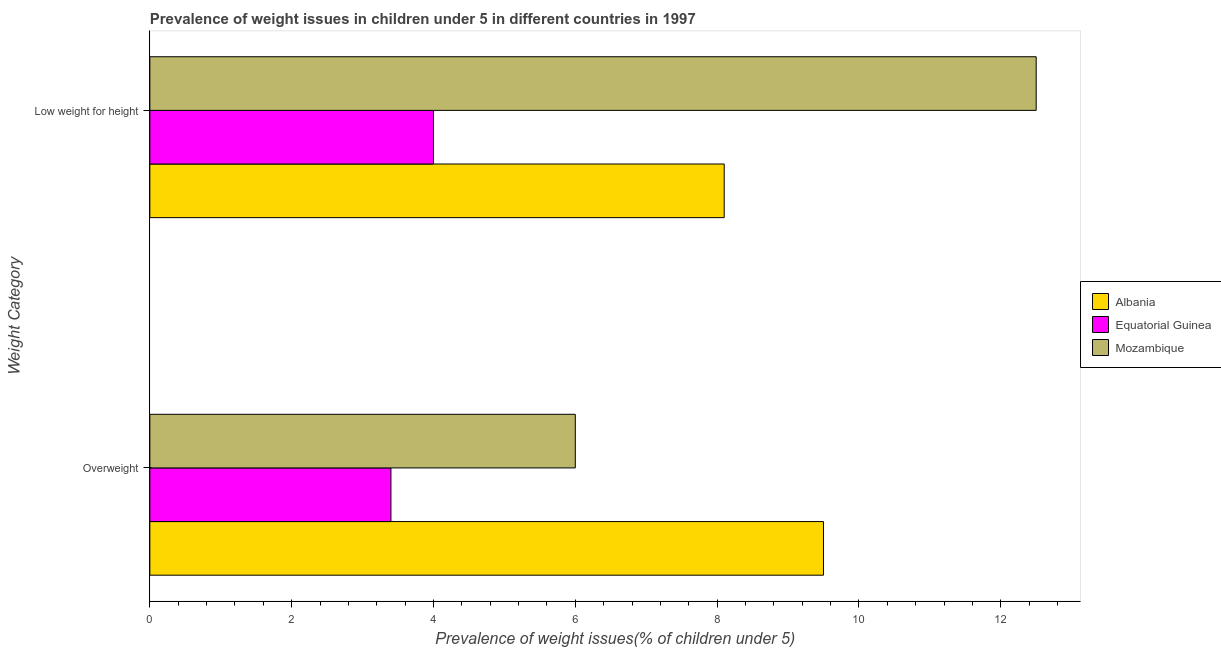How many different coloured bars are there?
Provide a short and direct response. 3. How many groups of bars are there?
Your answer should be very brief. 2. Are the number of bars on each tick of the Y-axis equal?
Keep it short and to the point. Yes. How many bars are there on the 2nd tick from the top?
Your answer should be compact. 3. What is the label of the 1st group of bars from the top?
Ensure brevity in your answer.  Low weight for height. Across all countries, what is the maximum percentage of overweight children?
Ensure brevity in your answer.  9.5. In which country was the percentage of overweight children maximum?
Keep it short and to the point. Albania. In which country was the percentage of underweight children minimum?
Provide a short and direct response. Equatorial Guinea. What is the total percentage of overweight children in the graph?
Give a very brief answer. 18.9. What is the difference between the percentage of overweight children in Albania and that in Equatorial Guinea?
Ensure brevity in your answer.  6.1. What is the difference between the percentage of underweight children in Albania and the percentage of overweight children in Mozambique?
Give a very brief answer. 2.1. What is the average percentage of underweight children per country?
Your answer should be very brief. 8.2. What is the difference between the percentage of underweight children and percentage of overweight children in Mozambique?
Provide a succinct answer. 6.5. In how many countries, is the percentage of overweight children greater than 8.4 %?
Offer a terse response. 1. What is the ratio of the percentage of overweight children in Albania to that in Equatorial Guinea?
Offer a terse response. 2.79. Is the percentage of overweight children in Equatorial Guinea less than that in Albania?
Keep it short and to the point. Yes. What does the 2nd bar from the top in Overweight represents?
Provide a short and direct response. Equatorial Guinea. What does the 1st bar from the bottom in Overweight represents?
Provide a short and direct response. Albania. Are all the bars in the graph horizontal?
Provide a short and direct response. Yes. How many countries are there in the graph?
Offer a very short reply. 3. Where does the legend appear in the graph?
Provide a succinct answer. Center right. What is the title of the graph?
Ensure brevity in your answer.  Prevalence of weight issues in children under 5 in different countries in 1997. What is the label or title of the X-axis?
Your answer should be compact. Prevalence of weight issues(% of children under 5). What is the label or title of the Y-axis?
Offer a very short reply. Weight Category. What is the Prevalence of weight issues(% of children under 5) in Equatorial Guinea in Overweight?
Keep it short and to the point. 3.4. What is the Prevalence of weight issues(% of children under 5) in Mozambique in Overweight?
Provide a succinct answer. 6. What is the Prevalence of weight issues(% of children under 5) of Albania in Low weight for height?
Your response must be concise. 8.1. What is the Prevalence of weight issues(% of children under 5) of Equatorial Guinea in Low weight for height?
Offer a terse response. 4. Across all Weight Category, what is the maximum Prevalence of weight issues(% of children under 5) of Albania?
Ensure brevity in your answer.  9.5. Across all Weight Category, what is the maximum Prevalence of weight issues(% of children under 5) of Equatorial Guinea?
Provide a short and direct response. 4. Across all Weight Category, what is the maximum Prevalence of weight issues(% of children under 5) of Mozambique?
Your answer should be very brief. 12.5. Across all Weight Category, what is the minimum Prevalence of weight issues(% of children under 5) of Albania?
Provide a succinct answer. 8.1. Across all Weight Category, what is the minimum Prevalence of weight issues(% of children under 5) in Equatorial Guinea?
Give a very brief answer. 3.4. Across all Weight Category, what is the minimum Prevalence of weight issues(% of children under 5) in Mozambique?
Offer a very short reply. 6. What is the total Prevalence of weight issues(% of children under 5) in Equatorial Guinea in the graph?
Your answer should be compact. 7.4. What is the total Prevalence of weight issues(% of children under 5) in Mozambique in the graph?
Your answer should be very brief. 18.5. What is the difference between the Prevalence of weight issues(% of children under 5) in Albania in Overweight and that in Low weight for height?
Make the answer very short. 1.4. What is the difference between the Prevalence of weight issues(% of children under 5) in Albania in Overweight and the Prevalence of weight issues(% of children under 5) in Equatorial Guinea in Low weight for height?
Your answer should be compact. 5.5. What is the average Prevalence of weight issues(% of children under 5) in Mozambique per Weight Category?
Make the answer very short. 9.25. What is the difference between the Prevalence of weight issues(% of children under 5) of Equatorial Guinea and Prevalence of weight issues(% of children under 5) of Mozambique in Overweight?
Your response must be concise. -2.6. What is the difference between the Prevalence of weight issues(% of children under 5) of Equatorial Guinea and Prevalence of weight issues(% of children under 5) of Mozambique in Low weight for height?
Provide a succinct answer. -8.5. What is the ratio of the Prevalence of weight issues(% of children under 5) of Albania in Overweight to that in Low weight for height?
Ensure brevity in your answer.  1.17. What is the ratio of the Prevalence of weight issues(% of children under 5) in Equatorial Guinea in Overweight to that in Low weight for height?
Your answer should be compact. 0.85. What is the ratio of the Prevalence of weight issues(% of children under 5) in Mozambique in Overweight to that in Low weight for height?
Give a very brief answer. 0.48. What is the difference between the highest and the lowest Prevalence of weight issues(% of children under 5) of Albania?
Ensure brevity in your answer.  1.4. What is the difference between the highest and the lowest Prevalence of weight issues(% of children under 5) in Equatorial Guinea?
Make the answer very short. 0.6. 